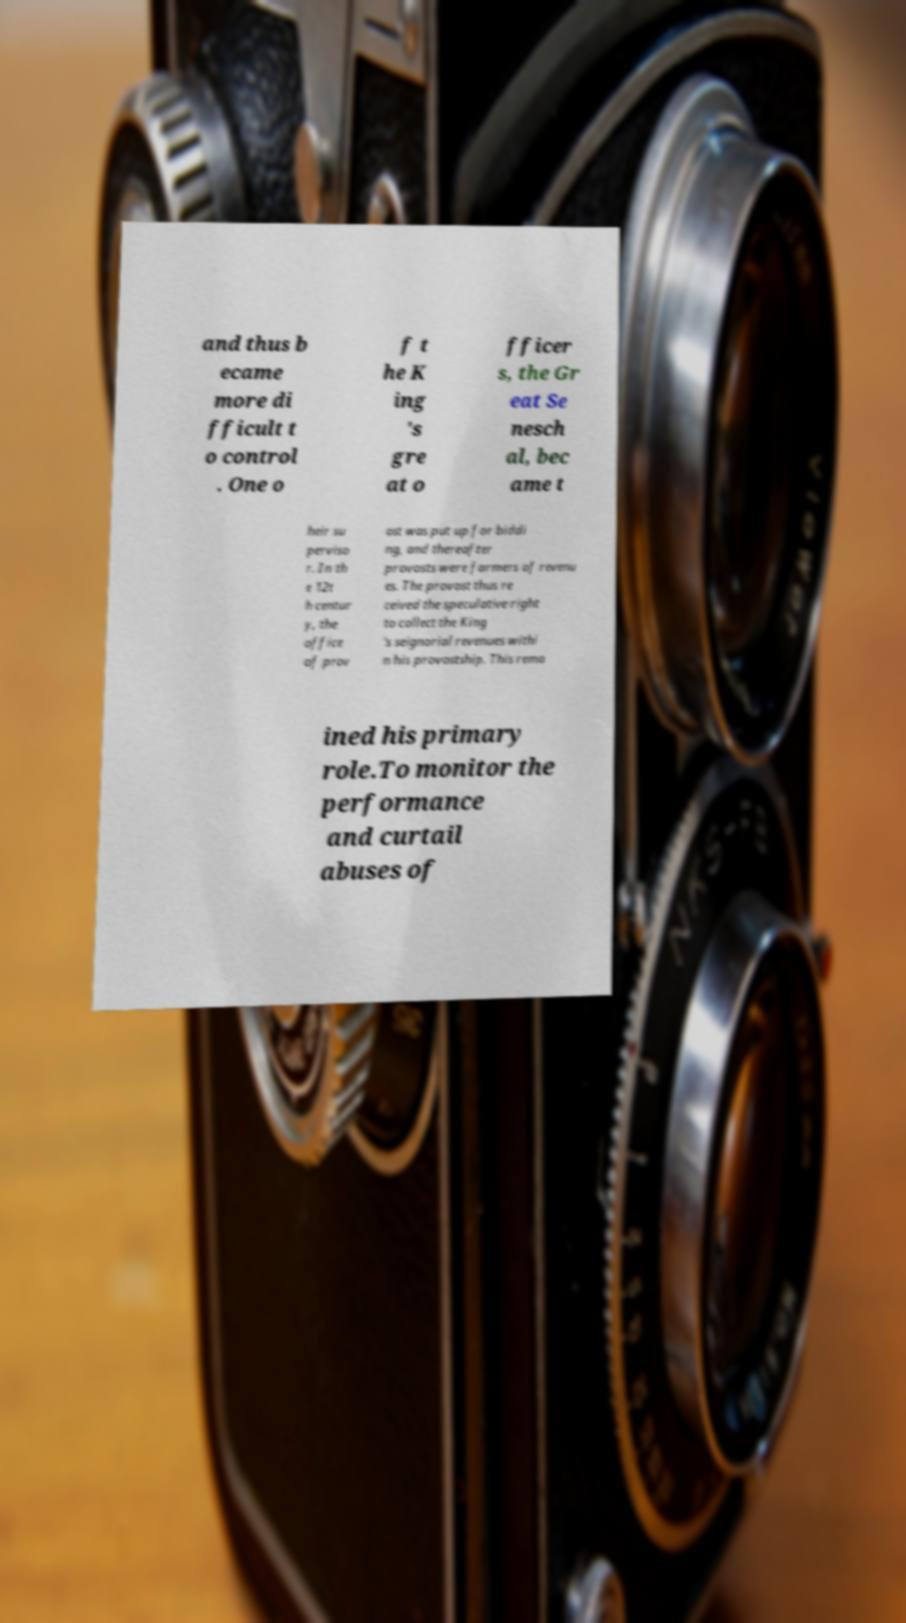There's text embedded in this image that I need extracted. Can you transcribe it verbatim? and thus b ecame more di fficult t o control . One o f t he K ing 's gre at o fficer s, the Gr eat Se nesch al, bec ame t heir su perviso r. In th e 12t h centur y, the office of prov ost was put up for biddi ng, and thereafter provosts were farmers of revenu es. The provost thus re ceived the speculative right to collect the King 's seignorial revenues withi n his provostship. This rema ined his primary role.To monitor the performance and curtail abuses of 